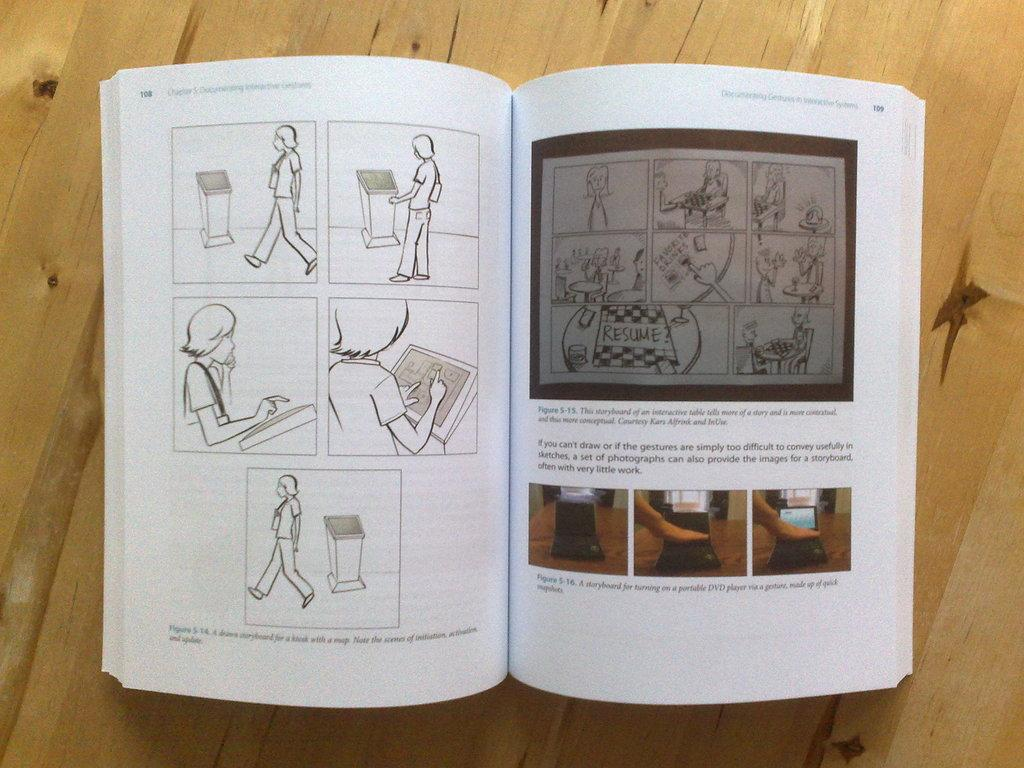<image>
Offer a succinct explanation of the picture presented. An open book shows cartoons on both pages including the one about resuming the chess game. 